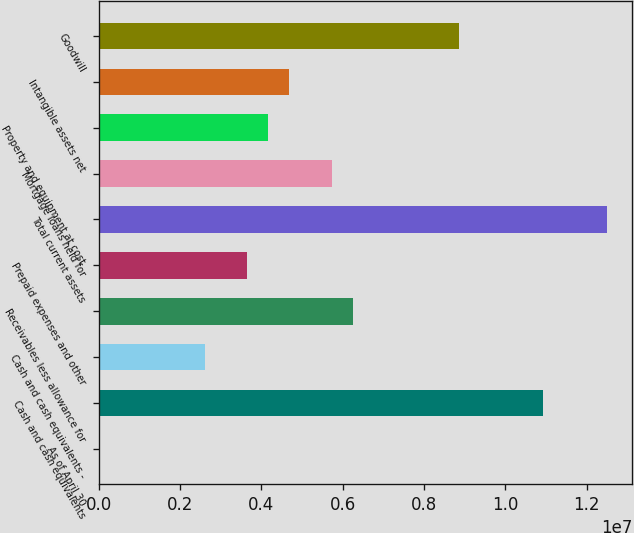<chart> <loc_0><loc_0><loc_500><loc_500><bar_chart><fcel>As of April 30<fcel>Cash and cash equivalents<fcel>Cash and cash equivalents -<fcel>Receivables less allowance for<fcel>Prepaid expenses and other<fcel>Total current assets<fcel>Mortgage loans held for<fcel>Property and equipment at cost<fcel>Intangible assets net<fcel>Goodwill<nl><fcel>2011<fcel>1.09345e+07<fcel>2.60499e+06<fcel>6.24915e+06<fcel>3.64618e+06<fcel>1.24963e+07<fcel>5.72856e+06<fcel>4.16677e+06<fcel>4.68737e+06<fcel>8.85213e+06<nl></chart> 